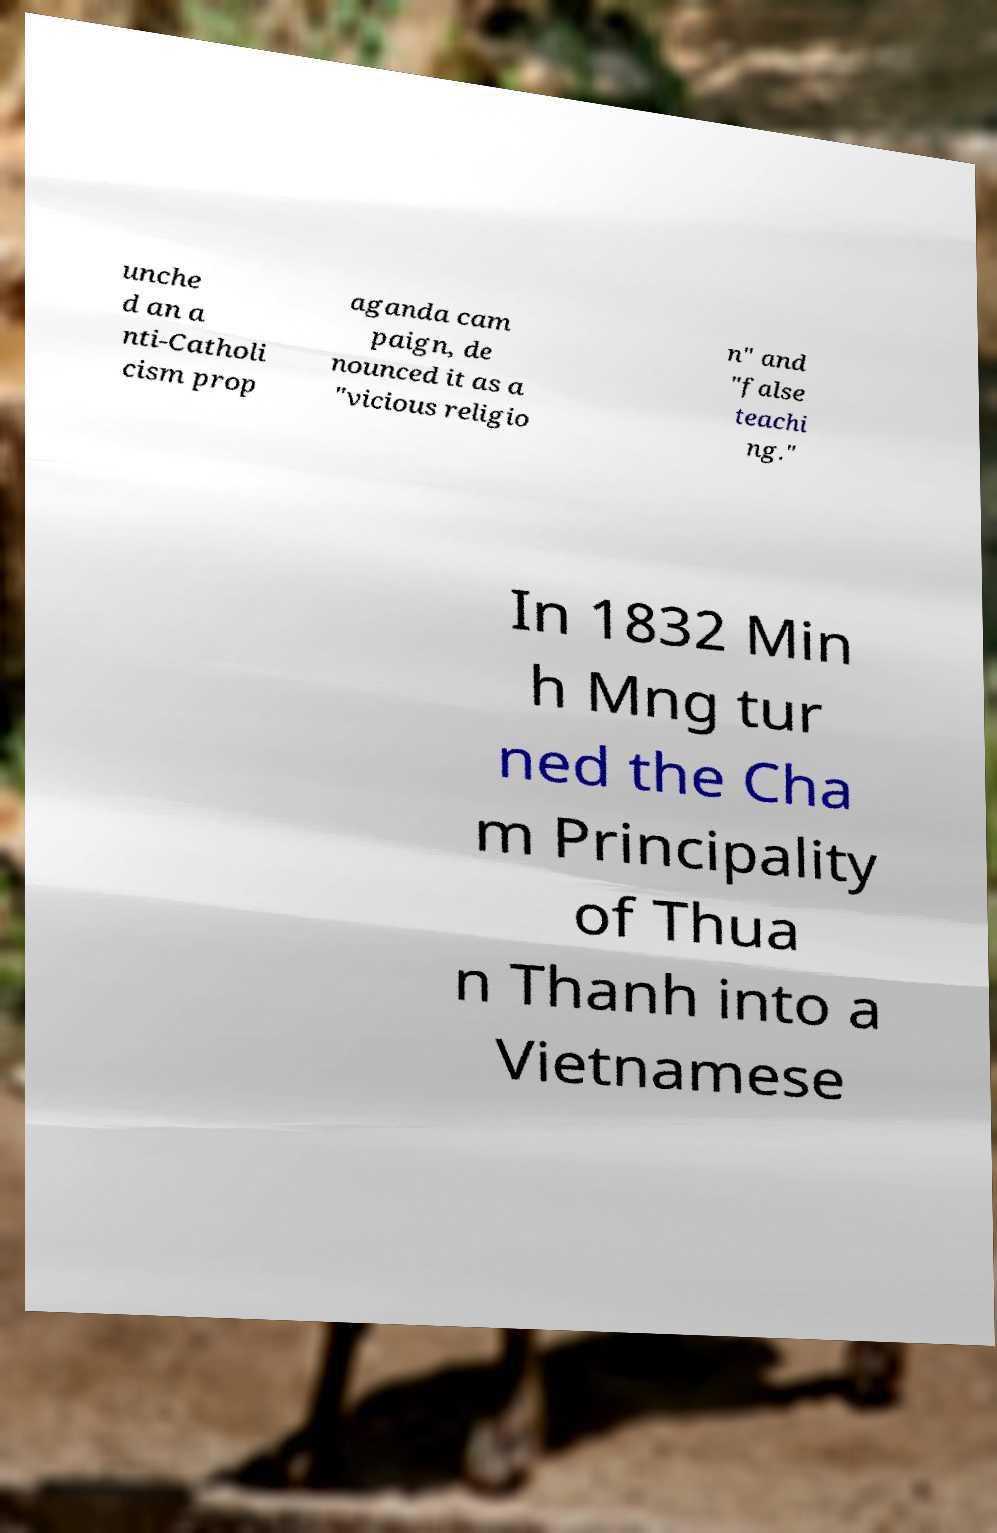Please read and relay the text visible in this image. What does it say? unche d an a nti-Catholi cism prop aganda cam paign, de nounced it as a "vicious religio n" and "false teachi ng." In 1832 Min h Mng tur ned the Cha m Principality of Thua n Thanh into a Vietnamese 